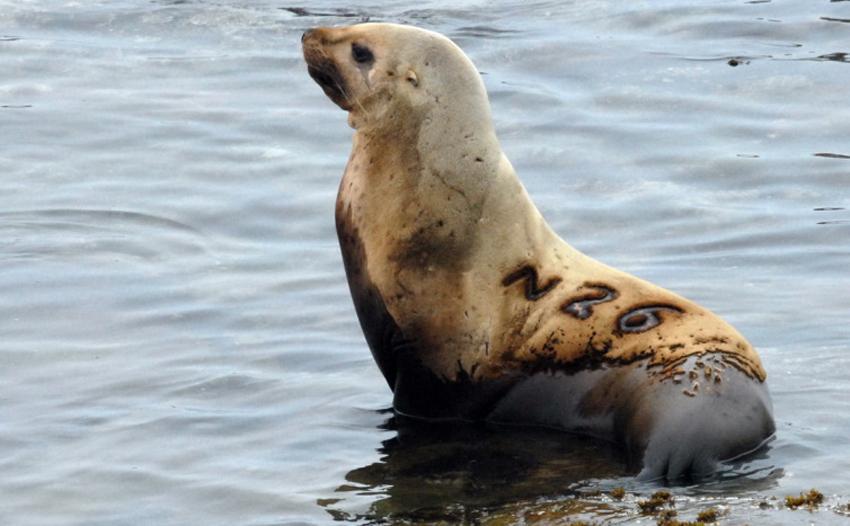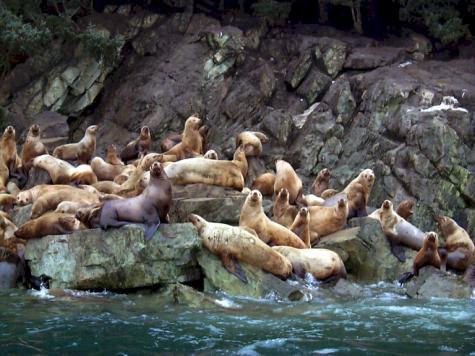The first image is the image on the left, the second image is the image on the right. Examine the images to the left and right. Is the description "There is one animal by the water in one of the images." accurate? Answer yes or no. Yes. The first image is the image on the left, the second image is the image on the right. Assess this claim about the two images: "An image shows a solitary sea lion facing left.". Correct or not? Answer yes or no. Yes. 